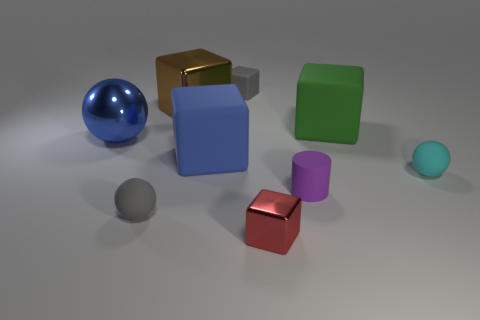How is lighting used to enhance the appearance of these objects? The lighting in the image is soft and diffused, which minimizes harsh shadows and allows the textures and colors of the objects to be clearly seen. It creates a calm and balanced atmosphere, emphasizing the material properties of each object. 